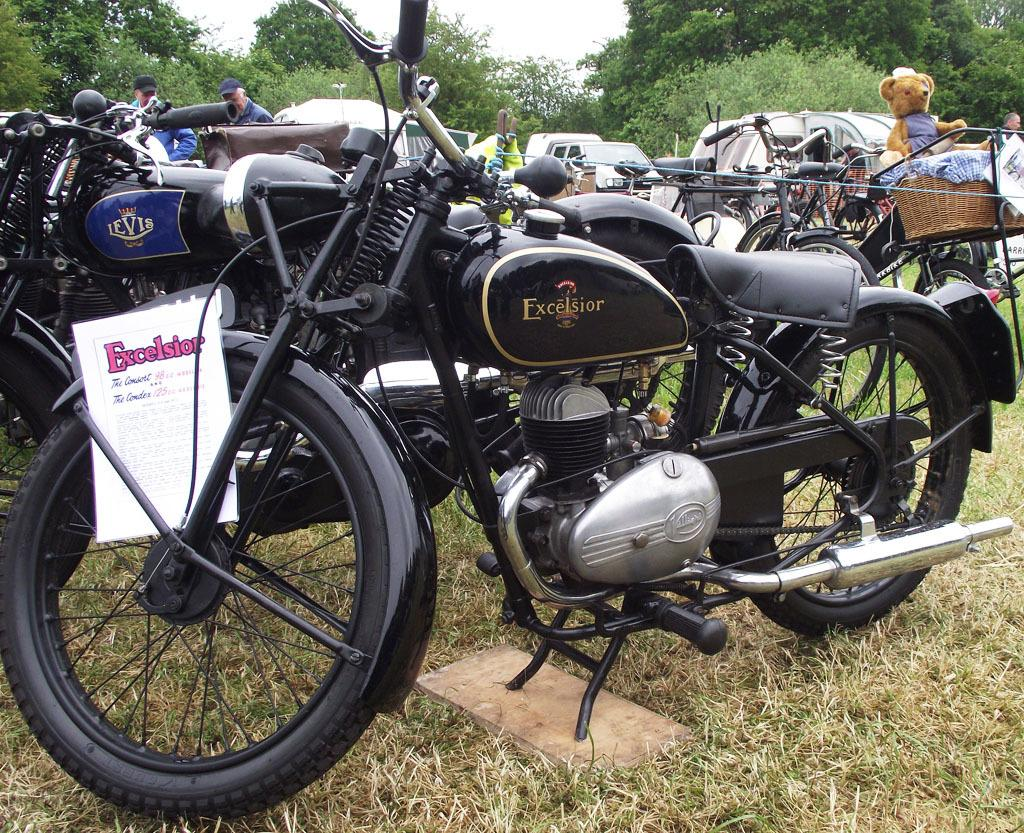What types of vehicles are on the grass in the image? There are motorbikes and bicycles on the grass in the image. What else can be found on the grass besides vehicles? There is a teddy in a basket on the grass. What is visible in the background of the image? There are trees in the background of the image. How many people are visible in the image? There are two people visible in the image. What is an unusual placement of an object in the image? A paper is on a wheel in the image. What is the size of the house in the image? There is no house present in the image. How do the people in the image pull the motorbikes? There is no indication in the image that the people are pulling the motorbikes; they are simply standing near them. 